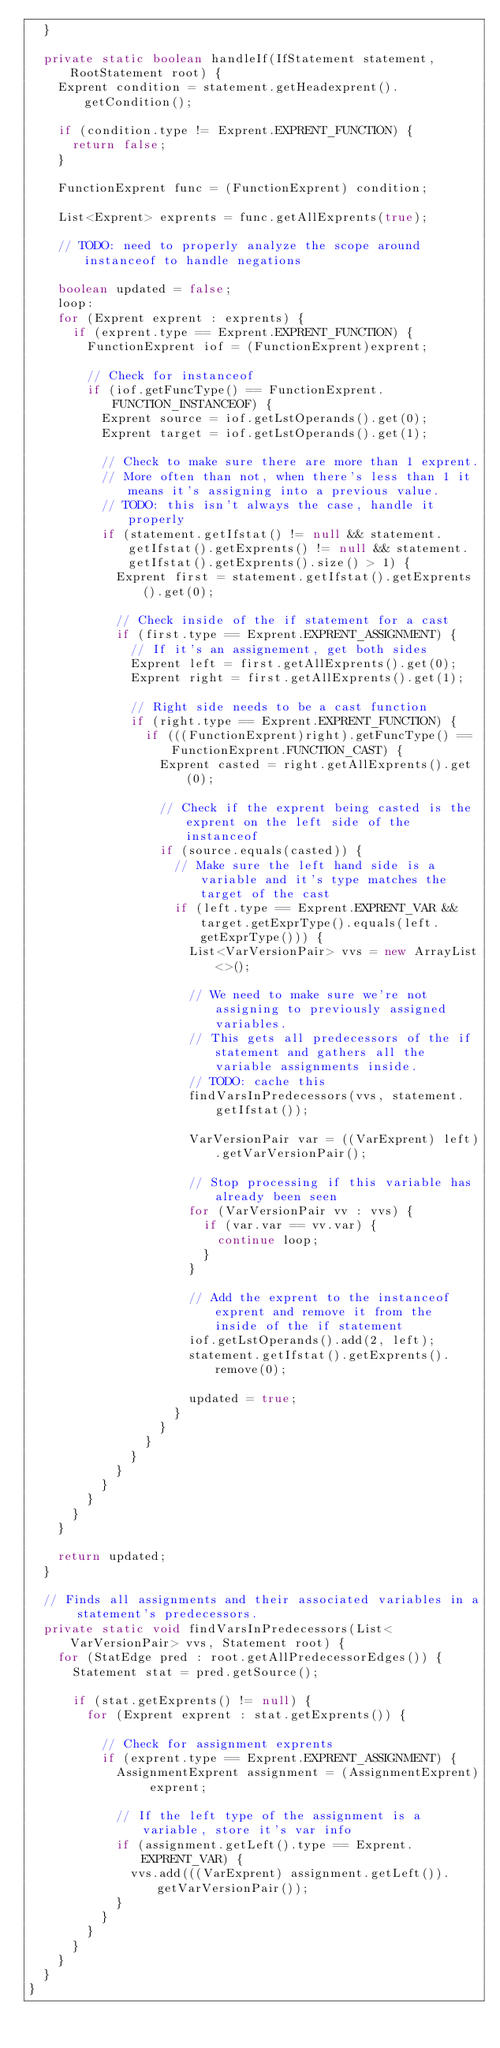<code> <loc_0><loc_0><loc_500><loc_500><_Java_>  }

  private static boolean handleIf(IfStatement statement, RootStatement root) {
    Exprent condition = statement.getHeadexprent().getCondition();

    if (condition.type != Exprent.EXPRENT_FUNCTION) {
      return false;
    }

    FunctionExprent func = (FunctionExprent) condition;

    List<Exprent> exprents = func.getAllExprents(true);

    // TODO: need to properly analyze the scope around instanceof to handle negations

    boolean updated = false;
    loop:
    for (Exprent exprent : exprents) {
      if (exprent.type == Exprent.EXPRENT_FUNCTION) {
        FunctionExprent iof = (FunctionExprent)exprent;

        // Check for instanceof
        if (iof.getFuncType() == FunctionExprent.FUNCTION_INSTANCEOF) {
          Exprent source = iof.getLstOperands().get(0);
          Exprent target = iof.getLstOperands().get(1);

          // Check to make sure there are more than 1 exprent.
          // More often than not, when there's less than 1 it means it's assigning into a previous value.
          // TODO: this isn't always the case, handle it properly
          if (statement.getIfstat() != null && statement.getIfstat().getExprents() != null && statement.getIfstat().getExprents().size() > 1) {
            Exprent first = statement.getIfstat().getExprents().get(0);

            // Check inside of the if statement for a cast
            if (first.type == Exprent.EXPRENT_ASSIGNMENT) {
              // If it's an assignement, get both sides
              Exprent left = first.getAllExprents().get(0);
              Exprent right = first.getAllExprents().get(1);

              // Right side needs to be a cast function
              if (right.type == Exprent.EXPRENT_FUNCTION) {
                if (((FunctionExprent)right).getFuncType() == FunctionExprent.FUNCTION_CAST) {
                  Exprent casted = right.getAllExprents().get(0);

                  // Check if the exprent being casted is the exprent on the left side of the instanceof
                  if (source.equals(casted)) {
                    // Make sure the left hand side is a variable and it's type matches the target of the cast
                    if (left.type == Exprent.EXPRENT_VAR && target.getExprType().equals(left.getExprType())) {
                      List<VarVersionPair> vvs = new ArrayList<>();

                      // We need to make sure we're not assigning to previously assigned variables.
                      // This gets all predecessors of the if statement and gathers all the variable assignments inside.
                      // TODO: cache this
                      findVarsInPredecessors(vvs, statement.getIfstat());

                      VarVersionPair var = ((VarExprent) left).getVarVersionPair();

                      // Stop processing if this variable has already been seen
                      for (VarVersionPair vv : vvs) {
                        if (var.var == vv.var) {
                          continue loop;
                        }
                      }

                      // Add the exprent to the instanceof exprent and remove it from the inside of the if statement
                      iof.getLstOperands().add(2, left);
                      statement.getIfstat().getExprents().remove(0);

                      updated = true;
                    }
                  }
                }
              }
            }
          }
        }
      }
    }

    return updated;
  }

  // Finds all assignments and their associated variables in a statement's predecessors.
  private static void findVarsInPredecessors(List<VarVersionPair> vvs, Statement root) {
    for (StatEdge pred : root.getAllPredecessorEdges()) {
      Statement stat = pred.getSource();

      if (stat.getExprents() != null) {
        for (Exprent exprent : stat.getExprents()) {

          // Check for assignment exprents
          if (exprent.type == Exprent.EXPRENT_ASSIGNMENT) {
            AssignmentExprent assignment = (AssignmentExprent) exprent;

            // If the left type of the assignment is a variable, store it's var info
            if (assignment.getLeft().type == Exprent.EXPRENT_VAR) {
              vvs.add(((VarExprent) assignment.getLeft()).getVarVersionPair());
            }
          }
        }
      }
    }
  }
}
</code> 